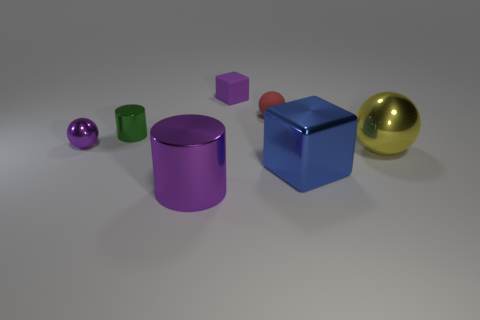Are there any green metallic cylinders behind the red matte object? no 